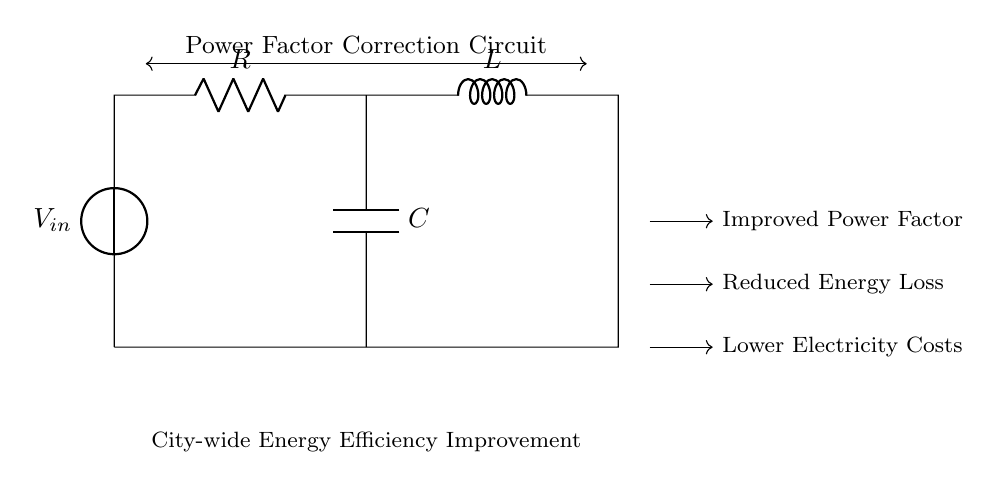What components are present in the circuit? The circuit diagram shows three key components: a resistor, an inductor, and a capacitor. These components are used together for power factor correction.
Answer: Resistor, inductor, capacitor What is the primary purpose of this circuit? The circuit serves to improve the power factor in an electrical system. The improved power factor leads to more efficient energy usage and reduced energy losses.
Answer: Power factor correction Which component is used for storing energy in a magnetic field? The inductor is the component responsible for storing energy in a magnetic field when an electric current passes through it.
Answer: Inductor How does the capacitor affect the circuit's power factor? The capacitor helps to counteract the lagging current caused by inductive loads, thereby improving the overall power factor of the circuit.
Answer: Improves power factor What is the benefit of using this circuit in a city-wide energy efficiency program? Implementing this circuit can lead to significantly lower electricity costs and reduced energy losses across the city's electrical infrastructure.
Answer: Lower electricity costs What type of circuit is represented by the components R, L, and C? This is a resonant RLC circuit, typically used for power factor correction by balancing resistive and reactive power in an AC circuit.
Answer: RLC circuit 